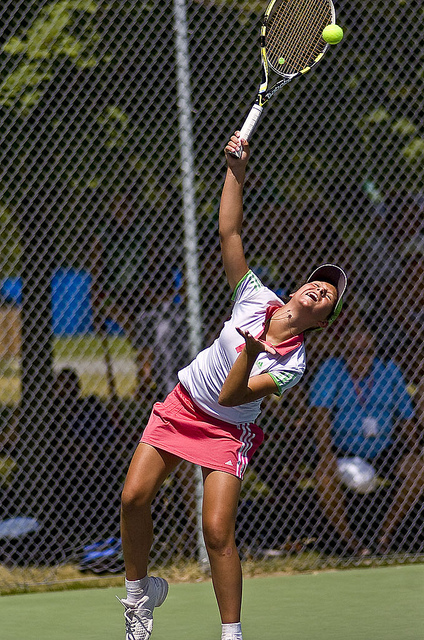What can you tell about the match setting from the background? The background shows a typical outdoor tennis court setting surrounded by fences and what appears to be spectator seating, suggesting that this could either be a practice session or a match in a park or club setting. The presence of dense trees further indicates a serene, perhaps less urban environment. 